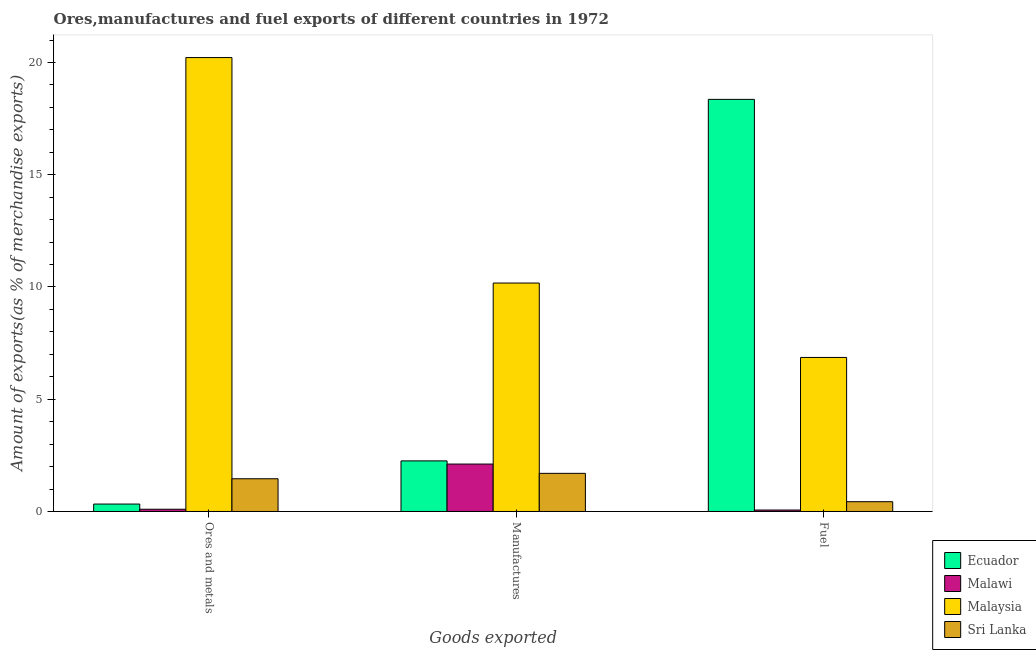How many different coloured bars are there?
Your answer should be compact. 4. Are the number of bars on each tick of the X-axis equal?
Make the answer very short. Yes. How many bars are there on the 1st tick from the left?
Ensure brevity in your answer.  4. How many bars are there on the 3rd tick from the right?
Your answer should be compact. 4. What is the label of the 1st group of bars from the left?
Give a very brief answer. Ores and metals. What is the percentage of manufactures exports in Sri Lanka?
Make the answer very short. 1.7. Across all countries, what is the maximum percentage of ores and metals exports?
Your answer should be compact. 20.22. Across all countries, what is the minimum percentage of ores and metals exports?
Provide a succinct answer. 0.1. In which country was the percentage of manufactures exports maximum?
Provide a succinct answer. Malaysia. In which country was the percentage of fuel exports minimum?
Give a very brief answer. Malawi. What is the total percentage of fuel exports in the graph?
Provide a succinct answer. 25.72. What is the difference between the percentage of fuel exports in Sri Lanka and that in Malaysia?
Ensure brevity in your answer.  -6.43. What is the difference between the percentage of manufactures exports in Ecuador and the percentage of ores and metals exports in Malawi?
Your response must be concise. 2.15. What is the average percentage of manufactures exports per country?
Ensure brevity in your answer.  4.06. What is the difference between the percentage of ores and metals exports and percentage of manufactures exports in Malaysia?
Your answer should be compact. 10.04. What is the ratio of the percentage of fuel exports in Ecuador to that in Malawi?
Make the answer very short. 281.53. Is the percentage of ores and metals exports in Ecuador less than that in Sri Lanka?
Give a very brief answer. Yes. What is the difference between the highest and the second highest percentage of fuel exports?
Provide a succinct answer. 11.5. What is the difference between the highest and the lowest percentage of fuel exports?
Provide a short and direct response. 18.29. Is the sum of the percentage of ores and metals exports in Sri Lanka and Malawi greater than the maximum percentage of fuel exports across all countries?
Your response must be concise. No. What does the 1st bar from the left in Fuel represents?
Offer a very short reply. Ecuador. What does the 4th bar from the right in Fuel represents?
Provide a short and direct response. Ecuador. Are all the bars in the graph horizontal?
Offer a very short reply. No. How many countries are there in the graph?
Offer a terse response. 4. Does the graph contain grids?
Make the answer very short. No. How many legend labels are there?
Provide a short and direct response. 4. How are the legend labels stacked?
Your answer should be compact. Vertical. What is the title of the graph?
Offer a very short reply. Ores,manufactures and fuel exports of different countries in 1972. Does "Afghanistan" appear as one of the legend labels in the graph?
Your answer should be compact. No. What is the label or title of the X-axis?
Ensure brevity in your answer.  Goods exported. What is the label or title of the Y-axis?
Ensure brevity in your answer.  Amount of exports(as % of merchandise exports). What is the Amount of exports(as % of merchandise exports) in Ecuador in Ores and metals?
Keep it short and to the point. 0.33. What is the Amount of exports(as % of merchandise exports) in Malawi in Ores and metals?
Your answer should be very brief. 0.1. What is the Amount of exports(as % of merchandise exports) of Malaysia in Ores and metals?
Make the answer very short. 20.22. What is the Amount of exports(as % of merchandise exports) in Sri Lanka in Ores and metals?
Make the answer very short. 1.46. What is the Amount of exports(as % of merchandise exports) of Ecuador in Manufactures?
Keep it short and to the point. 2.25. What is the Amount of exports(as % of merchandise exports) in Malawi in Manufactures?
Provide a succinct answer. 2.11. What is the Amount of exports(as % of merchandise exports) of Malaysia in Manufactures?
Give a very brief answer. 10.18. What is the Amount of exports(as % of merchandise exports) of Sri Lanka in Manufactures?
Offer a terse response. 1.7. What is the Amount of exports(as % of merchandise exports) in Ecuador in Fuel?
Make the answer very short. 18.36. What is the Amount of exports(as % of merchandise exports) of Malawi in Fuel?
Offer a very short reply. 0.07. What is the Amount of exports(as % of merchandise exports) of Malaysia in Fuel?
Provide a succinct answer. 6.86. What is the Amount of exports(as % of merchandise exports) in Sri Lanka in Fuel?
Provide a succinct answer. 0.44. Across all Goods exported, what is the maximum Amount of exports(as % of merchandise exports) in Ecuador?
Offer a very short reply. 18.36. Across all Goods exported, what is the maximum Amount of exports(as % of merchandise exports) in Malawi?
Keep it short and to the point. 2.11. Across all Goods exported, what is the maximum Amount of exports(as % of merchandise exports) of Malaysia?
Provide a succinct answer. 20.22. Across all Goods exported, what is the maximum Amount of exports(as % of merchandise exports) of Sri Lanka?
Keep it short and to the point. 1.7. Across all Goods exported, what is the minimum Amount of exports(as % of merchandise exports) in Ecuador?
Offer a very short reply. 0.33. Across all Goods exported, what is the minimum Amount of exports(as % of merchandise exports) of Malawi?
Your answer should be compact. 0.07. Across all Goods exported, what is the minimum Amount of exports(as % of merchandise exports) of Malaysia?
Offer a very short reply. 6.86. Across all Goods exported, what is the minimum Amount of exports(as % of merchandise exports) of Sri Lanka?
Offer a very short reply. 0.44. What is the total Amount of exports(as % of merchandise exports) of Ecuador in the graph?
Ensure brevity in your answer.  20.94. What is the total Amount of exports(as % of merchandise exports) in Malawi in the graph?
Your response must be concise. 2.28. What is the total Amount of exports(as % of merchandise exports) of Malaysia in the graph?
Make the answer very short. 37.26. What is the total Amount of exports(as % of merchandise exports) in Sri Lanka in the graph?
Give a very brief answer. 3.59. What is the difference between the Amount of exports(as % of merchandise exports) of Ecuador in Ores and metals and that in Manufactures?
Provide a short and direct response. -1.92. What is the difference between the Amount of exports(as % of merchandise exports) of Malawi in Ores and metals and that in Manufactures?
Offer a very short reply. -2.01. What is the difference between the Amount of exports(as % of merchandise exports) in Malaysia in Ores and metals and that in Manufactures?
Keep it short and to the point. 10.04. What is the difference between the Amount of exports(as % of merchandise exports) of Sri Lanka in Ores and metals and that in Manufactures?
Keep it short and to the point. -0.24. What is the difference between the Amount of exports(as % of merchandise exports) of Ecuador in Ores and metals and that in Fuel?
Provide a short and direct response. -18.03. What is the difference between the Amount of exports(as % of merchandise exports) of Malawi in Ores and metals and that in Fuel?
Your answer should be very brief. 0.03. What is the difference between the Amount of exports(as % of merchandise exports) of Malaysia in Ores and metals and that in Fuel?
Offer a terse response. 13.36. What is the difference between the Amount of exports(as % of merchandise exports) of Ecuador in Manufactures and that in Fuel?
Your answer should be compact. -16.1. What is the difference between the Amount of exports(as % of merchandise exports) of Malawi in Manufactures and that in Fuel?
Ensure brevity in your answer.  2.05. What is the difference between the Amount of exports(as % of merchandise exports) in Malaysia in Manufactures and that in Fuel?
Ensure brevity in your answer.  3.31. What is the difference between the Amount of exports(as % of merchandise exports) of Sri Lanka in Manufactures and that in Fuel?
Your answer should be compact. 1.26. What is the difference between the Amount of exports(as % of merchandise exports) in Ecuador in Ores and metals and the Amount of exports(as % of merchandise exports) in Malawi in Manufactures?
Make the answer very short. -1.78. What is the difference between the Amount of exports(as % of merchandise exports) in Ecuador in Ores and metals and the Amount of exports(as % of merchandise exports) in Malaysia in Manufactures?
Ensure brevity in your answer.  -9.85. What is the difference between the Amount of exports(as % of merchandise exports) of Ecuador in Ores and metals and the Amount of exports(as % of merchandise exports) of Sri Lanka in Manufactures?
Make the answer very short. -1.37. What is the difference between the Amount of exports(as % of merchandise exports) of Malawi in Ores and metals and the Amount of exports(as % of merchandise exports) of Malaysia in Manufactures?
Give a very brief answer. -10.08. What is the difference between the Amount of exports(as % of merchandise exports) in Malawi in Ores and metals and the Amount of exports(as % of merchandise exports) in Sri Lanka in Manufactures?
Keep it short and to the point. -1.6. What is the difference between the Amount of exports(as % of merchandise exports) in Malaysia in Ores and metals and the Amount of exports(as % of merchandise exports) in Sri Lanka in Manufactures?
Your answer should be compact. 18.52. What is the difference between the Amount of exports(as % of merchandise exports) of Ecuador in Ores and metals and the Amount of exports(as % of merchandise exports) of Malawi in Fuel?
Provide a succinct answer. 0.27. What is the difference between the Amount of exports(as % of merchandise exports) in Ecuador in Ores and metals and the Amount of exports(as % of merchandise exports) in Malaysia in Fuel?
Your answer should be compact. -6.53. What is the difference between the Amount of exports(as % of merchandise exports) in Ecuador in Ores and metals and the Amount of exports(as % of merchandise exports) in Sri Lanka in Fuel?
Your response must be concise. -0.1. What is the difference between the Amount of exports(as % of merchandise exports) in Malawi in Ores and metals and the Amount of exports(as % of merchandise exports) in Malaysia in Fuel?
Make the answer very short. -6.76. What is the difference between the Amount of exports(as % of merchandise exports) in Malawi in Ores and metals and the Amount of exports(as % of merchandise exports) in Sri Lanka in Fuel?
Keep it short and to the point. -0.34. What is the difference between the Amount of exports(as % of merchandise exports) in Malaysia in Ores and metals and the Amount of exports(as % of merchandise exports) in Sri Lanka in Fuel?
Ensure brevity in your answer.  19.78. What is the difference between the Amount of exports(as % of merchandise exports) of Ecuador in Manufactures and the Amount of exports(as % of merchandise exports) of Malawi in Fuel?
Provide a succinct answer. 2.19. What is the difference between the Amount of exports(as % of merchandise exports) in Ecuador in Manufactures and the Amount of exports(as % of merchandise exports) in Malaysia in Fuel?
Keep it short and to the point. -4.61. What is the difference between the Amount of exports(as % of merchandise exports) in Ecuador in Manufactures and the Amount of exports(as % of merchandise exports) in Sri Lanka in Fuel?
Give a very brief answer. 1.82. What is the difference between the Amount of exports(as % of merchandise exports) in Malawi in Manufactures and the Amount of exports(as % of merchandise exports) in Malaysia in Fuel?
Your answer should be compact. -4.75. What is the difference between the Amount of exports(as % of merchandise exports) in Malawi in Manufactures and the Amount of exports(as % of merchandise exports) in Sri Lanka in Fuel?
Your response must be concise. 1.68. What is the difference between the Amount of exports(as % of merchandise exports) of Malaysia in Manufactures and the Amount of exports(as % of merchandise exports) of Sri Lanka in Fuel?
Offer a very short reply. 9.74. What is the average Amount of exports(as % of merchandise exports) in Ecuador per Goods exported?
Your answer should be very brief. 6.98. What is the average Amount of exports(as % of merchandise exports) of Malawi per Goods exported?
Provide a short and direct response. 0.76. What is the average Amount of exports(as % of merchandise exports) in Malaysia per Goods exported?
Make the answer very short. 12.42. What is the average Amount of exports(as % of merchandise exports) in Sri Lanka per Goods exported?
Give a very brief answer. 1.2. What is the difference between the Amount of exports(as % of merchandise exports) in Ecuador and Amount of exports(as % of merchandise exports) in Malawi in Ores and metals?
Ensure brevity in your answer.  0.23. What is the difference between the Amount of exports(as % of merchandise exports) in Ecuador and Amount of exports(as % of merchandise exports) in Malaysia in Ores and metals?
Make the answer very short. -19.89. What is the difference between the Amount of exports(as % of merchandise exports) of Ecuador and Amount of exports(as % of merchandise exports) of Sri Lanka in Ores and metals?
Ensure brevity in your answer.  -1.13. What is the difference between the Amount of exports(as % of merchandise exports) in Malawi and Amount of exports(as % of merchandise exports) in Malaysia in Ores and metals?
Make the answer very short. -20.12. What is the difference between the Amount of exports(as % of merchandise exports) of Malawi and Amount of exports(as % of merchandise exports) of Sri Lanka in Ores and metals?
Provide a succinct answer. -1.36. What is the difference between the Amount of exports(as % of merchandise exports) in Malaysia and Amount of exports(as % of merchandise exports) in Sri Lanka in Ores and metals?
Ensure brevity in your answer.  18.76. What is the difference between the Amount of exports(as % of merchandise exports) of Ecuador and Amount of exports(as % of merchandise exports) of Malawi in Manufactures?
Give a very brief answer. 0.14. What is the difference between the Amount of exports(as % of merchandise exports) of Ecuador and Amount of exports(as % of merchandise exports) of Malaysia in Manufactures?
Offer a very short reply. -7.92. What is the difference between the Amount of exports(as % of merchandise exports) in Ecuador and Amount of exports(as % of merchandise exports) in Sri Lanka in Manufactures?
Give a very brief answer. 0.55. What is the difference between the Amount of exports(as % of merchandise exports) in Malawi and Amount of exports(as % of merchandise exports) in Malaysia in Manufactures?
Keep it short and to the point. -8.06. What is the difference between the Amount of exports(as % of merchandise exports) of Malawi and Amount of exports(as % of merchandise exports) of Sri Lanka in Manufactures?
Offer a terse response. 0.41. What is the difference between the Amount of exports(as % of merchandise exports) in Malaysia and Amount of exports(as % of merchandise exports) in Sri Lanka in Manufactures?
Offer a terse response. 8.48. What is the difference between the Amount of exports(as % of merchandise exports) in Ecuador and Amount of exports(as % of merchandise exports) in Malawi in Fuel?
Offer a very short reply. 18.29. What is the difference between the Amount of exports(as % of merchandise exports) in Ecuador and Amount of exports(as % of merchandise exports) in Malaysia in Fuel?
Give a very brief answer. 11.5. What is the difference between the Amount of exports(as % of merchandise exports) in Ecuador and Amount of exports(as % of merchandise exports) in Sri Lanka in Fuel?
Provide a succinct answer. 17.92. What is the difference between the Amount of exports(as % of merchandise exports) in Malawi and Amount of exports(as % of merchandise exports) in Malaysia in Fuel?
Give a very brief answer. -6.8. What is the difference between the Amount of exports(as % of merchandise exports) in Malawi and Amount of exports(as % of merchandise exports) in Sri Lanka in Fuel?
Your response must be concise. -0.37. What is the difference between the Amount of exports(as % of merchandise exports) of Malaysia and Amount of exports(as % of merchandise exports) of Sri Lanka in Fuel?
Your answer should be compact. 6.43. What is the ratio of the Amount of exports(as % of merchandise exports) in Ecuador in Ores and metals to that in Manufactures?
Provide a succinct answer. 0.15. What is the ratio of the Amount of exports(as % of merchandise exports) in Malawi in Ores and metals to that in Manufactures?
Your answer should be very brief. 0.05. What is the ratio of the Amount of exports(as % of merchandise exports) of Malaysia in Ores and metals to that in Manufactures?
Your answer should be compact. 1.99. What is the ratio of the Amount of exports(as % of merchandise exports) of Sri Lanka in Ores and metals to that in Manufactures?
Your response must be concise. 0.86. What is the ratio of the Amount of exports(as % of merchandise exports) of Ecuador in Ores and metals to that in Fuel?
Ensure brevity in your answer.  0.02. What is the ratio of the Amount of exports(as % of merchandise exports) in Malawi in Ores and metals to that in Fuel?
Ensure brevity in your answer.  1.53. What is the ratio of the Amount of exports(as % of merchandise exports) in Malaysia in Ores and metals to that in Fuel?
Ensure brevity in your answer.  2.95. What is the ratio of the Amount of exports(as % of merchandise exports) in Sri Lanka in Ores and metals to that in Fuel?
Offer a very short reply. 3.35. What is the ratio of the Amount of exports(as % of merchandise exports) in Ecuador in Manufactures to that in Fuel?
Make the answer very short. 0.12. What is the ratio of the Amount of exports(as % of merchandise exports) in Malawi in Manufactures to that in Fuel?
Make the answer very short. 32.4. What is the ratio of the Amount of exports(as % of merchandise exports) in Malaysia in Manufactures to that in Fuel?
Make the answer very short. 1.48. What is the ratio of the Amount of exports(as % of merchandise exports) in Sri Lanka in Manufactures to that in Fuel?
Your answer should be very brief. 3.9. What is the difference between the highest and the second highest Amount of exports(as % of merchandise exports) in Ecuador?
Make the answer very short. 16.1. What is the difference between the highest and the second highest Amount of exports(as % of merchandise exports) in Malawi?
Give a very brief answer. 2.01. What is the difference between the highest and the second highest Amount of exports(as % of merchandise exports) in Malaysia?
Ensure brevity in your answer.  10.04. What is the difference between the highest and the second highest Amount of exports(as % of merchandise exports) in Sri Lanka?
Offer a terse response. 0.24. What is the difference between the highest and the lowest Amount of exports(as % of merchandise exports) of Ecuador?
Offer a terse response. 18.03. What is the difference between the highest and the lowest Amount of exports(as % of merchandise exports) of Malawi?
Your answer should be compact. 2.05. What is the difference between the highest and the lowest Amount of exports(as % of merchandise exports) of Malaysia?
Make the answer very short. 13.36. What is the difference between the highest and the lowest Amount of exports(as % of merchandise exports) of Sri Lanka?
Provide a short and direct response. 1.26. 